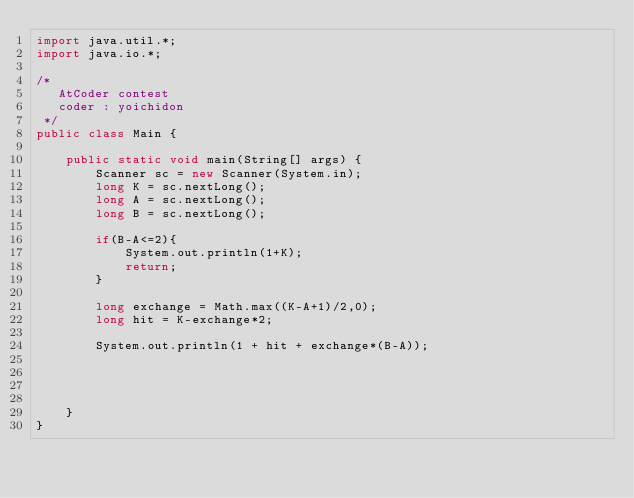<code> <loc_0><loc_0><loc_500><loc_500><_Java_>import java.util.*;
import java.io.*;

/*
   AtCoder contest
   coder : yoichidon
 */
public class Main {

    public static void main(String[] args) {
        Scanner sc = new Scanner(System.in);
        long K = sc.nextLong();
        long A = sc.nextLong();
        long B = sc.nextLong();

        if(B-A<=2){
            System.out.println(1+K);
            return;
        }

        long exchange = Math.max((K-A+1)/2,0);
        long hit = K-exchange*2;

        System.out.println(1 + hit + exchange*(B-A));




    }
}
</code> 